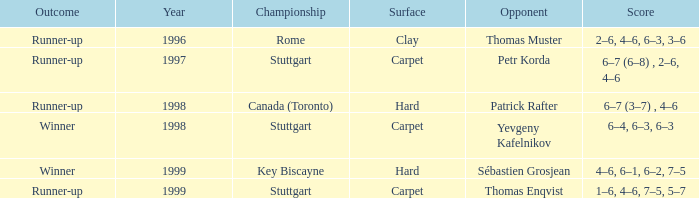What was the outcome before 1997? Runner-up. Could you help me parse every detail presented in this table? {'header': ['Outcome', 'Year', 'Championship', 'Surface', 'Opponent', 'Score'], 'rows': [['Runner-up', '1996', 'Rome', 'Clay', 'Thomas Muster', '2–6, 4–6, 6–3, 3–6'], ['Runner-up', '1997', 'Stuttgart', 'Carpet', 'Petr Korda', '6–7 (6–8) , 2–6, 4–6'], ['Runner-up', '1998', 'Canada (Toronto)', 'Hard', 'Patrick Rafter', '6–7 (3–7) , 4–6'], ['Winner', '1998', 'Stuttgart', 'Carpet', 'Yevgeny Kafelnikov', '6–4, 6–3, 6–3'], ['Winner', '1999', 'Key Biscayne', 'Hard', 'Sébastien Grosjean', '4–6, 6–1, 6–2, 7–5'], ['Runner-up', '1999', 'Stuttgart', 'Carpet', 'Thomas Enqvist', '1–6, 4–6, 7–5, 5–7']]} 